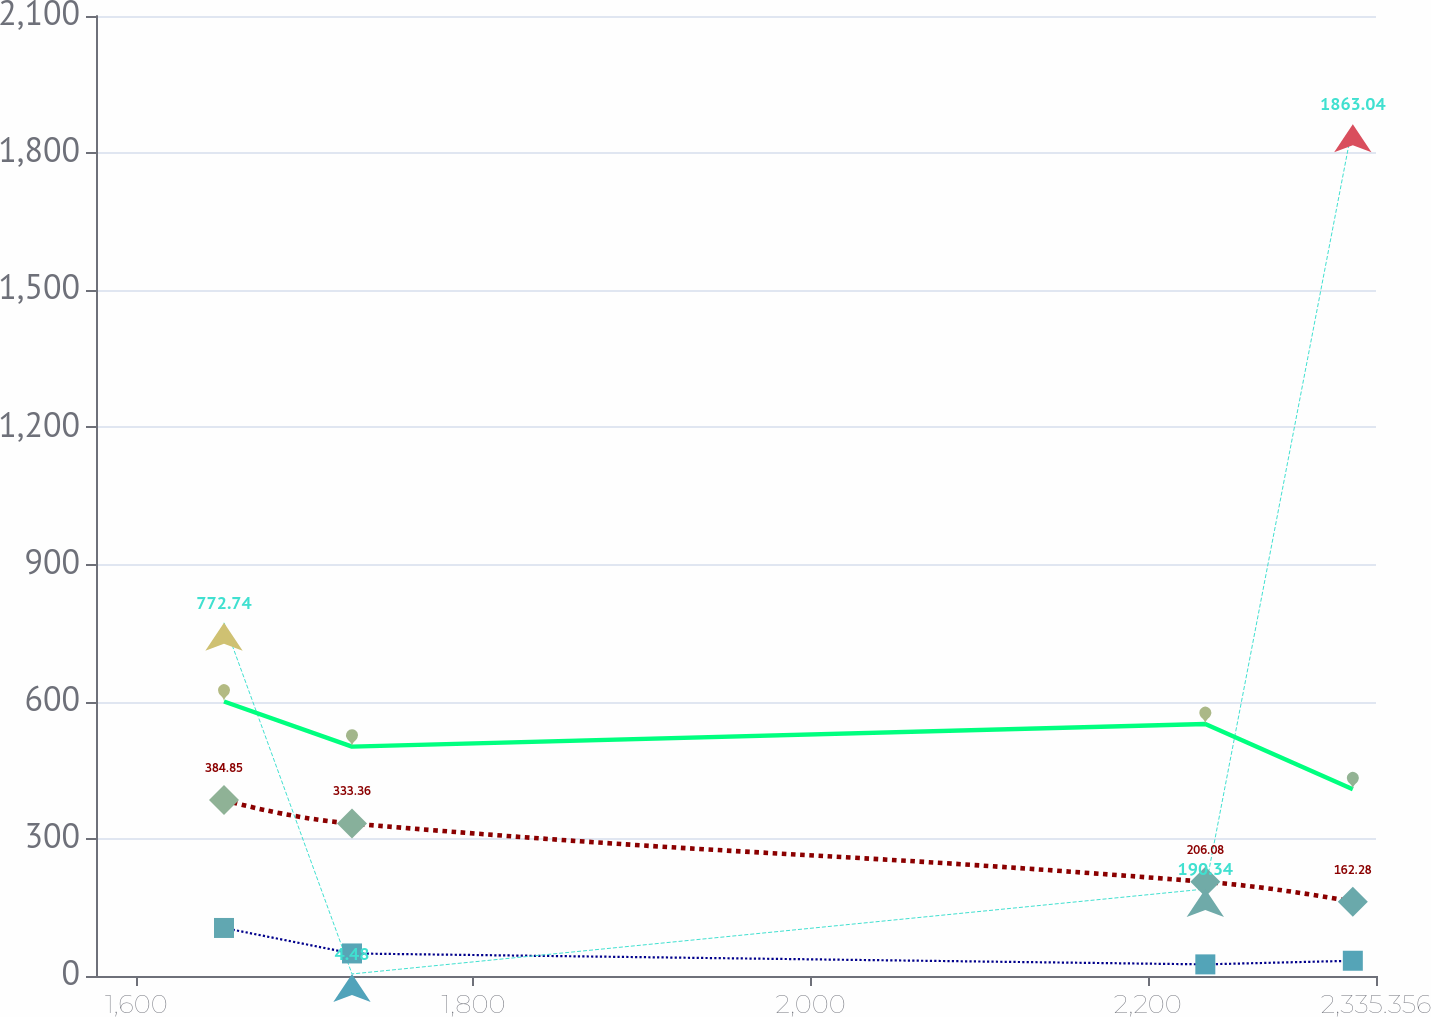Convert chart. <chart><loc_0><loc_0><loc_500><loc_500><line_chart><ecel><fcel>Purchase Commitments<fcel>Capital Leases<fcel>Operating Leases<fcel>Debt Principal<nl><fcel>1652.04<fcel>105.08<fcel>384.85<fcel>772.74<fcel>600.41<nl><fcel>1727.96<fcel>49.32<fcel>333.36<fcel>4.48<fcel>501.85<nl><fcel>2234.12<fcel>25.41<fcel>206.08<fcel>190.34<fcel>551.13<nl><fcel>2321.61<fcel>33.38<fcel>162.28<fcel>1863.04<fcel>408.4<nl><fcel>2411.28<fcel>41.35<fcel>117.77<fcel>1166.17<fcel>66.13<nl></chart> 